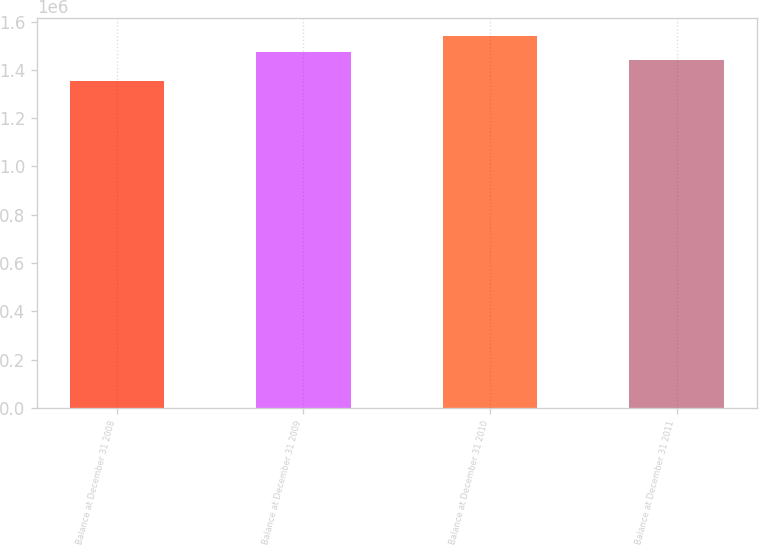Convert chart. <chart><loc_0><loc_0><loc_500><loc_500><bar_chart><fcel>Balance at December 31 2008<fcel>Balance at December 31 2009<fcel>Balance at December 31 2010<fcel>Balance at December 31 2011<nl><fcel>1.35241e+06<fcel>1.47393e+06<fcel>1.53952e+06<fcel>1.43973e+06<nl></chart> 